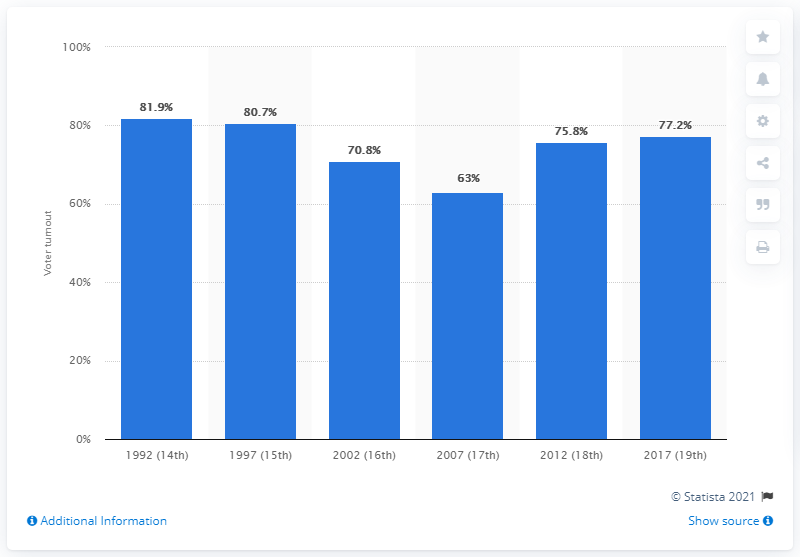Draw attention to some important aspects in this diagram. During the 18th presidential election in South Korea, the voter turnout was 77.2%. 